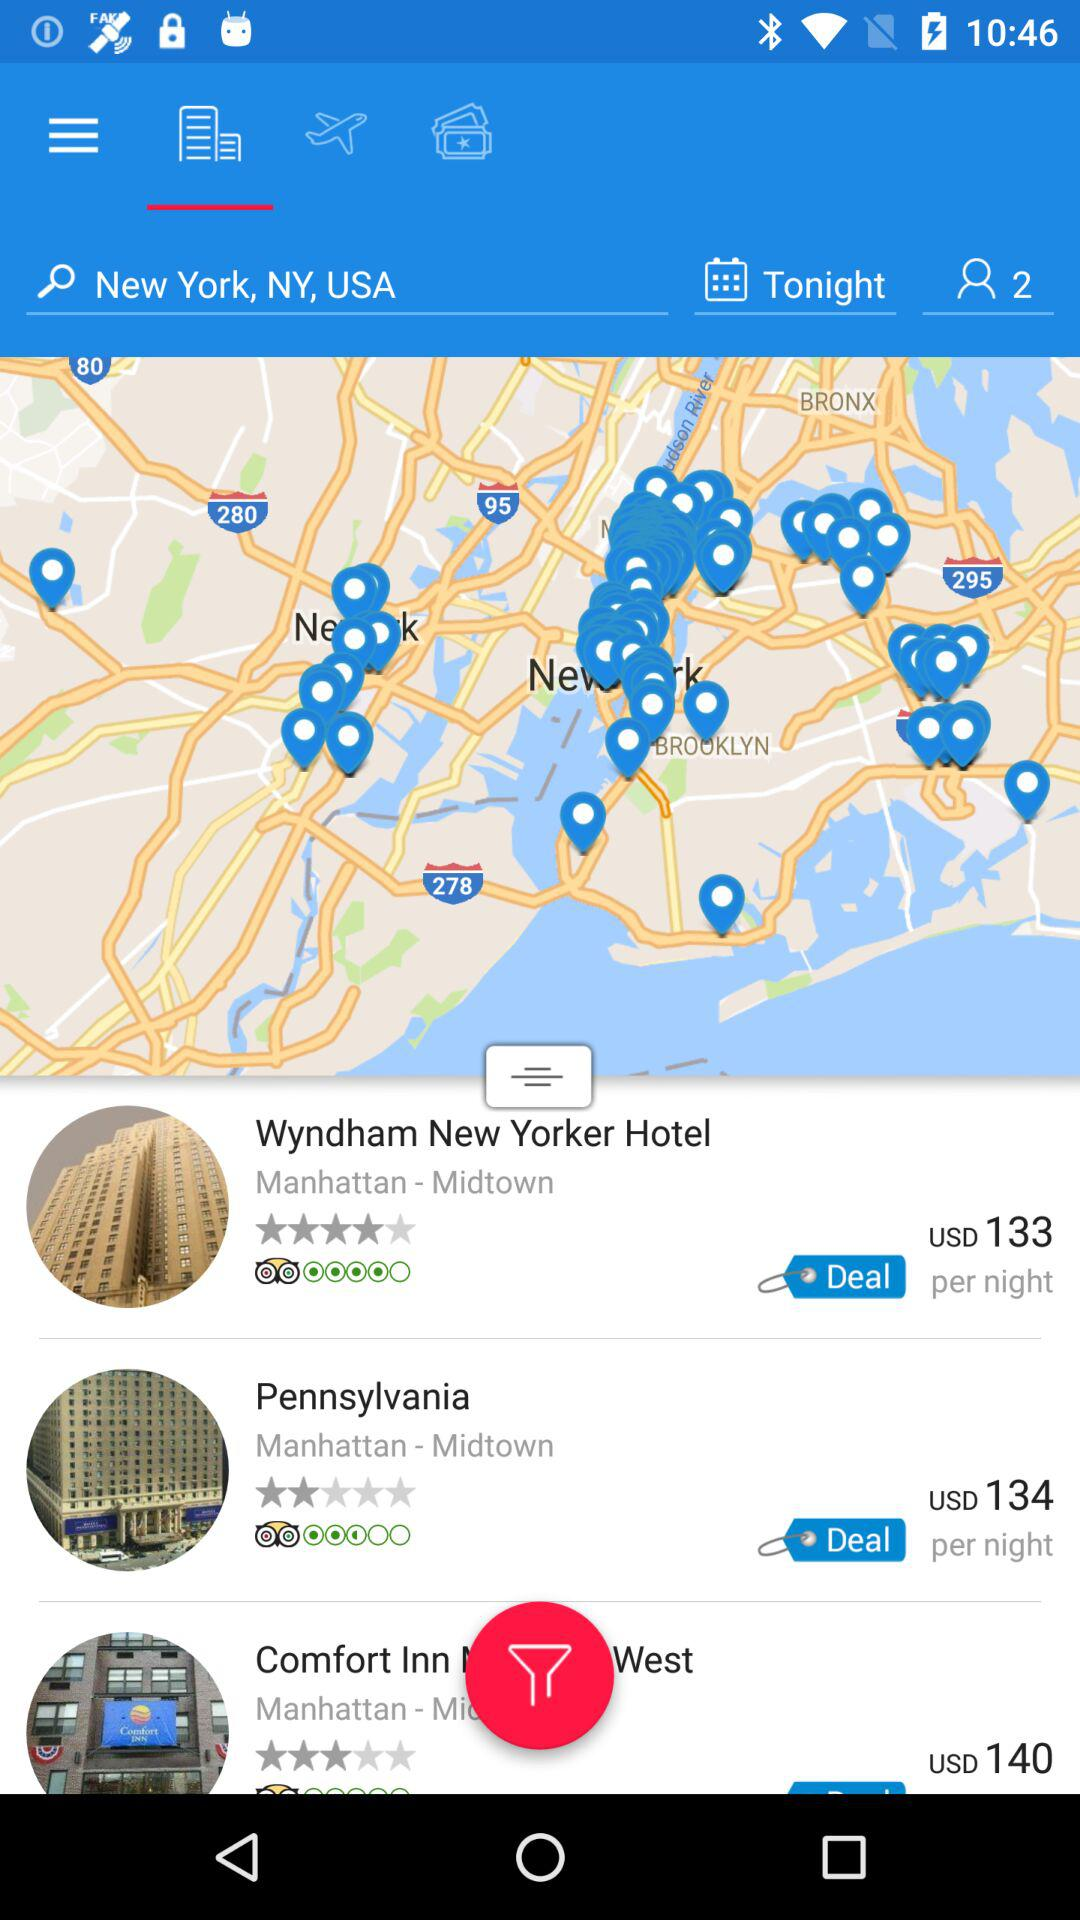What is the rating for "Pennsylvania"? The rating is 2 stars. 